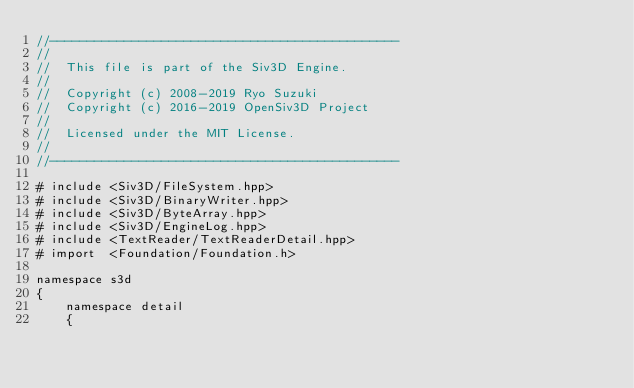<code> <loc_0><loc_0><loc_500><loc_500><_ObjectiveC_>//-----------------------------------------------
//
//	This file is part of the Siv3D Engine.
//
//	Copyright (c) 2008-2019 Ryo Suzuki
//	Copyright (c) 2016-2019 OpenSiv3D Project
//
//	Licensed under the MIT License.
//
//-----------------------------------------------

# include <Siv3D/FileSystem.hpp>
# include <Siv3D/BinaryWriter.hpp>
# include <Siv3D/ByteArray.hpp>
# include <Siv3D/EngineLog.hpp>
# include <TextReader/TextReaderDetail.hpp>
# import  <Foundation/Foundation.h>

namespace s3d
{
	namespace detail
	{</code> 